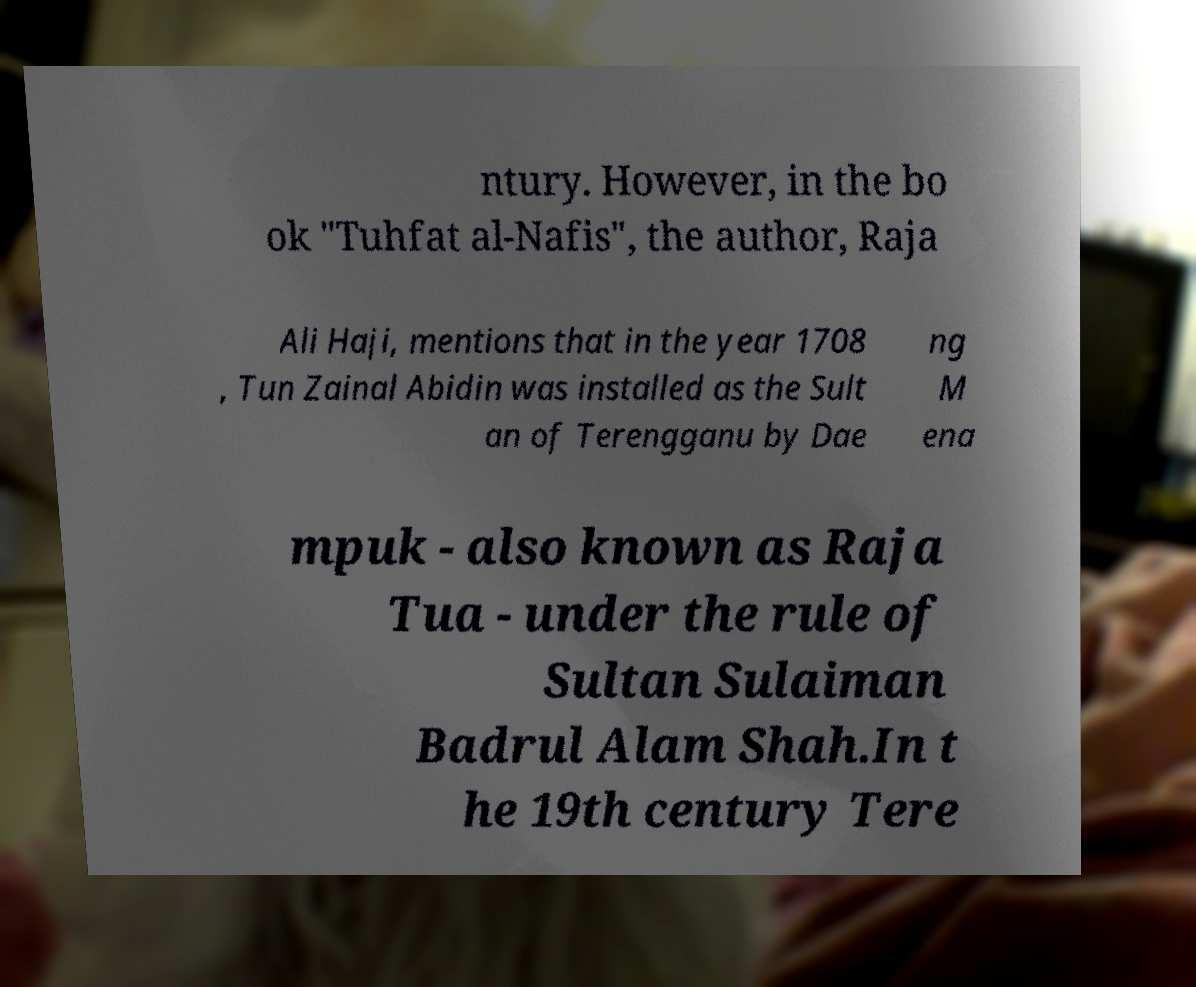Can you accurately transcribe the text from the provided image for me? ntury. However, in the bo ok "Tuhfat al-Nafis", the author, Raja Ali Haji, mentions that in the year 1708 , Tun Zainal Abidin was installed as the Sult an of Terengganu by Dae ng M ena mpuk - also known as Raja Tua - under the rule of Sultan Sulaiman Badrul Alam Shah.In t he 19th century Tere 